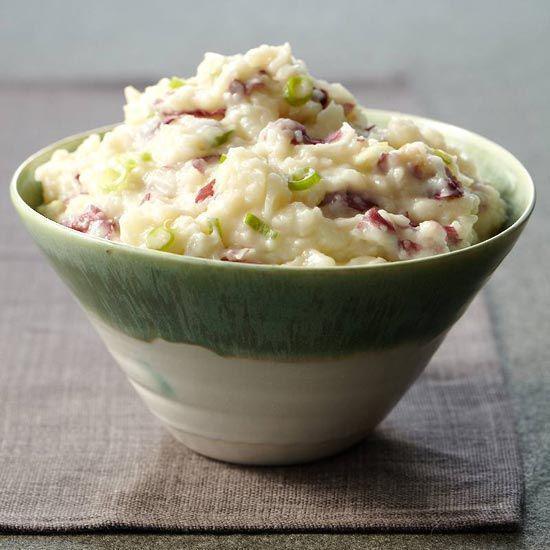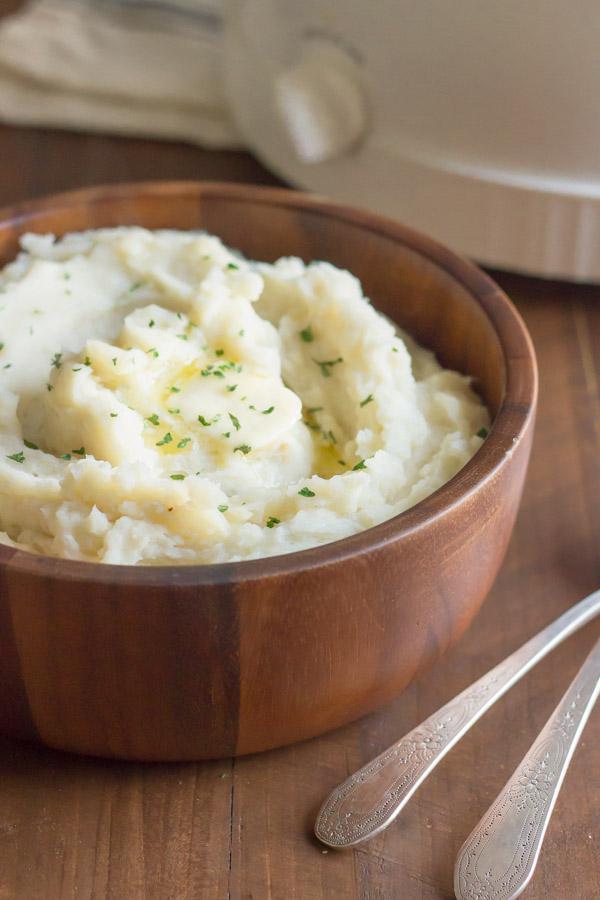The first image is the image on the left, the second image is the image on the right. Analyze the images presented: Is the assertion "An image shows a piece of silverware on a surface to the right of a bowl of potatoes." valid? Answer yes or no. Yes. The first image is the image on the left, the second image is the image on the right. Analyze the images presented: Is the assertion "A white bowl of mashed potato is on top of a round placemat." valid? Answer yes or no. No. 